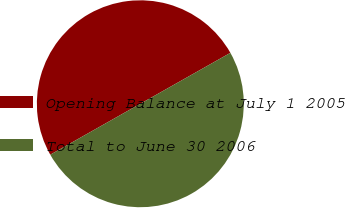<chart> <loc_0><loc_0><loc_500><loc_500><pie_chart><fcel>Opening Balance at July 1 2005<fcel>Total to June 30 2006<nl><fcel>50.0%<fcel>50.0%<nl></chart> 